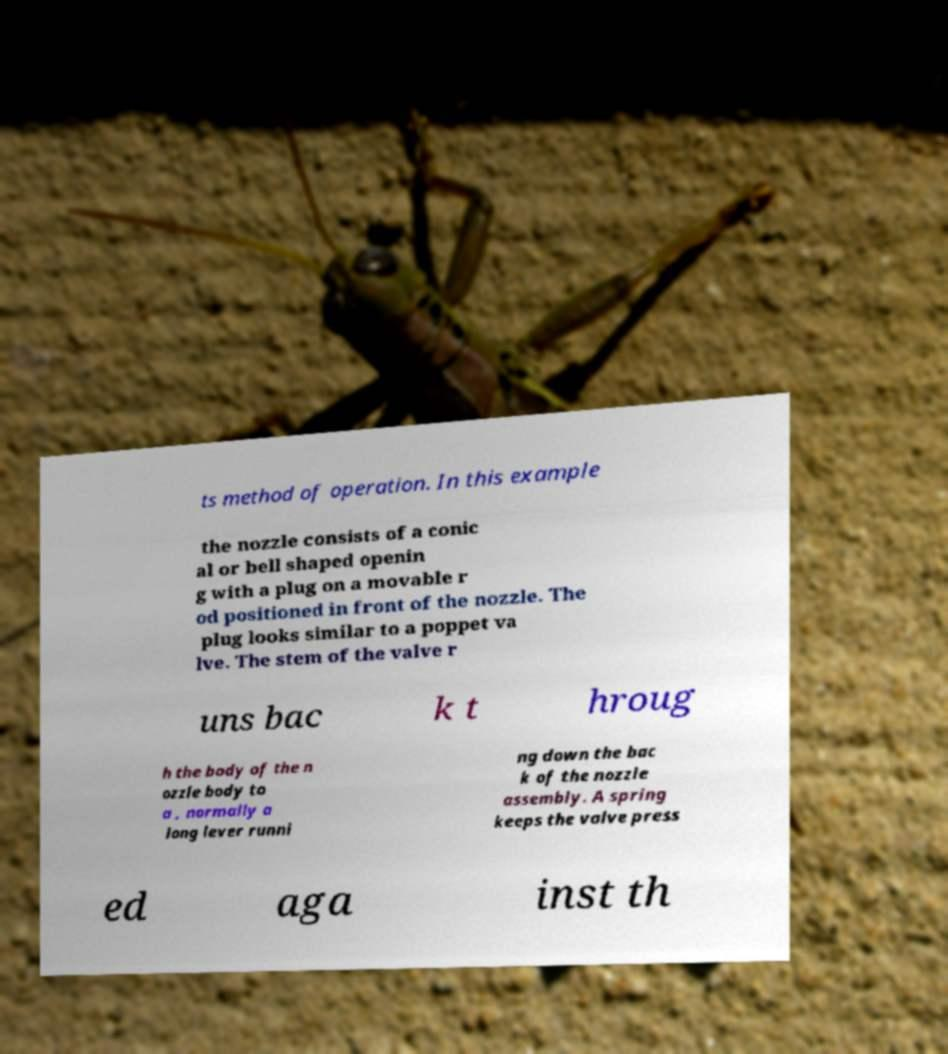Could you extract and type out the text from this image? ts method of operation. In this example the nozzle consists of a conic al or bell shaped openin g with a plug on a movable r od positioned in front of the nozzle. The plug looks similar to a poppet va lve. The stem of the valve r uns bac k t hroug h the body of the n ozzle body to a , normally a long lever runni ng down the bac k of the nozzle assembly. A spring keeps the valve press ed aga inst th 